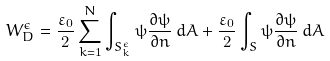<formula> <loc_0><loc_0><loc_500><loc_500>W _ { D } ^ { \epsilon } = \frac { \varepsilon _ { 0 } } { 2 } \sum _ { k = 1 } ^ { N } \int _ { S _ { k } ^ { \epsilon } } \psi \frac { \partial \psi } { \partial { n } } \, d { A } + \frac { \varepsilon _ { 0 } } { 2 } \int _ { S } \psi \frac { \partial \psi } { \partial { n } } \, d { A }</formula> 